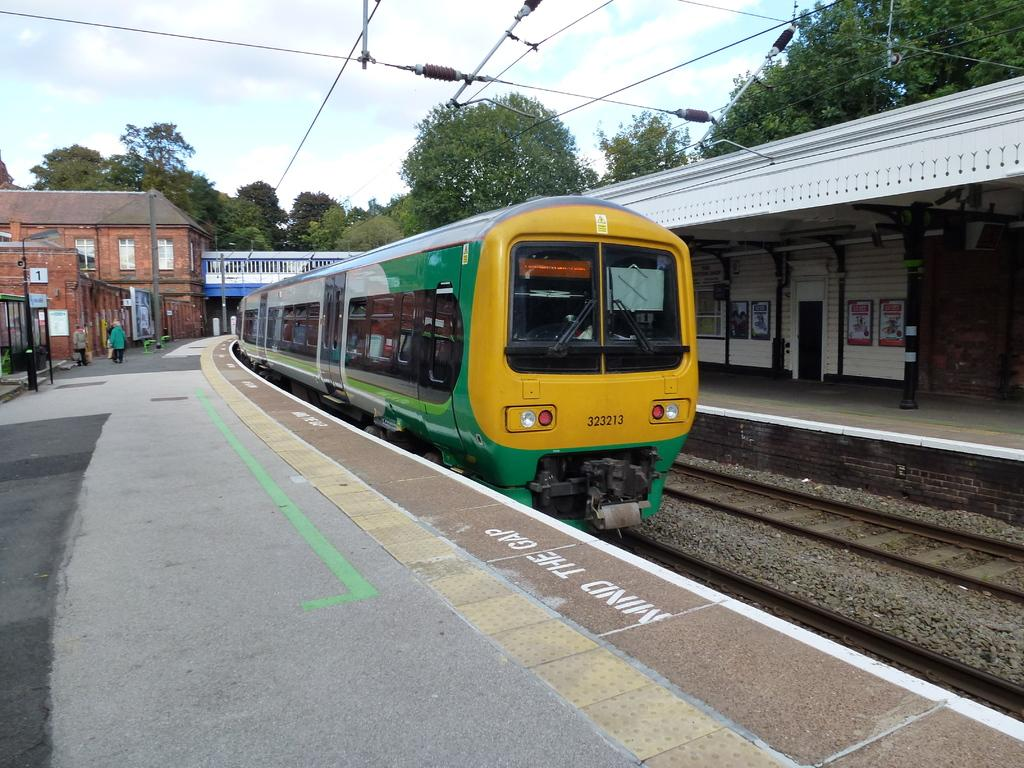Provide a one-sentence caption for the provided image. the train number 323213 is leaving a station. 